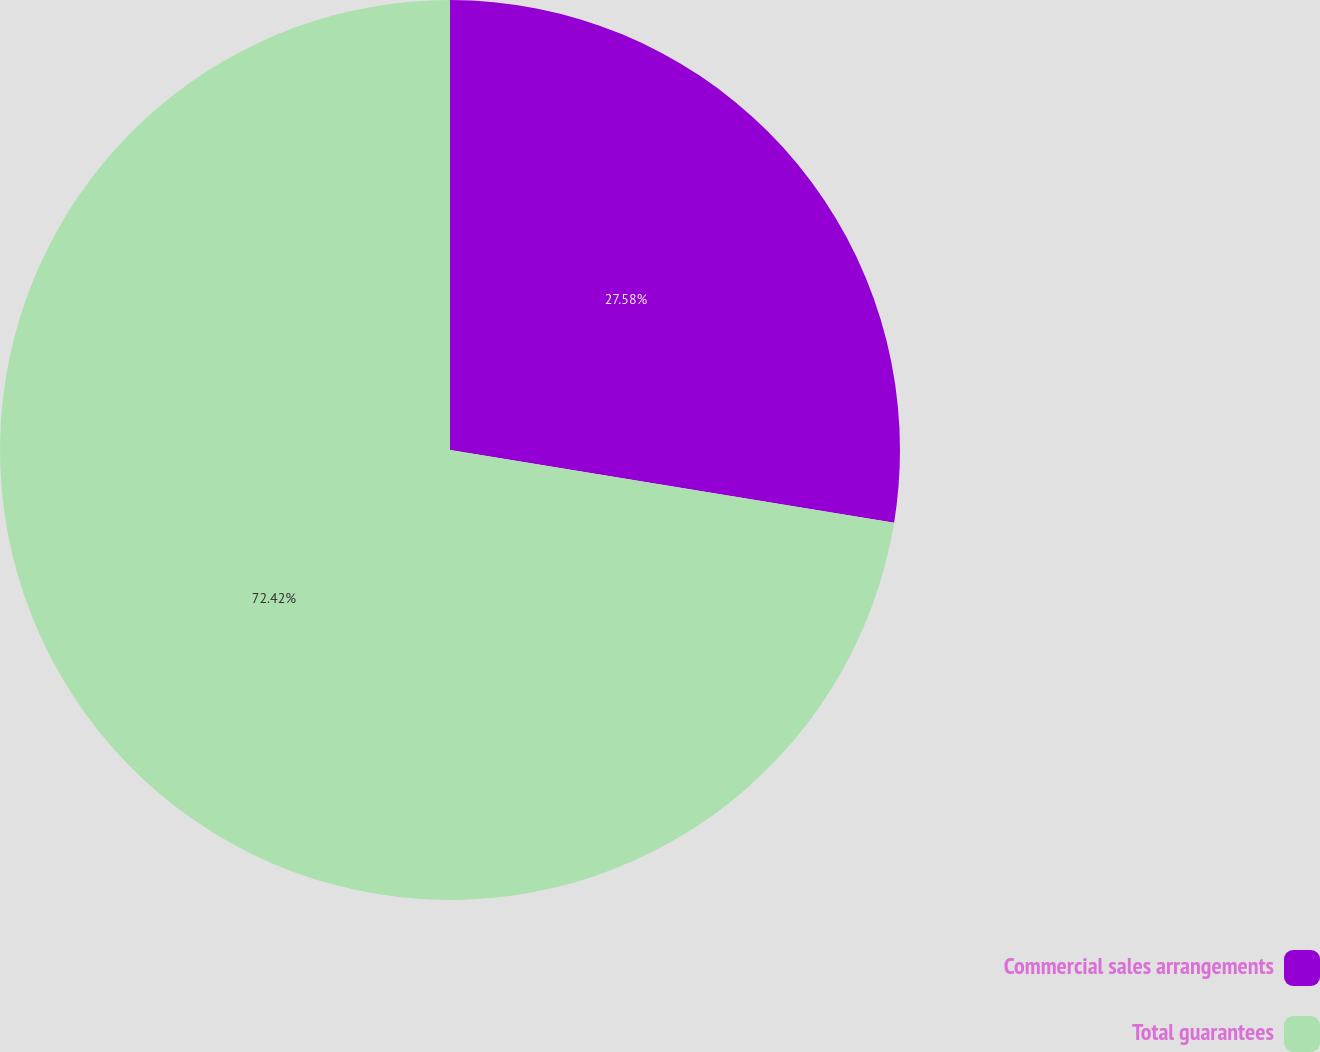<chart> <loc_0><loc_0><loc_500><loc_500><pie_chart><fcel>Commercial sales arrangements<fcel>Total guarantees<nl><fcel>27.58%<fcel>72.42%<nl></chart> 